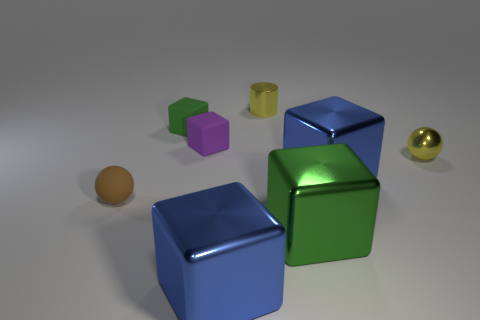Subtract all purple cubes. How many cubes are left? 4 Subtract all green matte blocks. How many blocks are left? 4 Subtract all brown blocks. Subtract all brown cylinders. How many blocks are left? 5 Add 2 big blue metal objects. How many objects exist? 10 Subtract all balls. How many objects are left? 6 Add 5 small yellow balls. How many small yellow balls are left? 6 Add 5 small green things. How many small green things exist? 6 Subtract 2 green blocks. How many objects are left? 6 Subtract all large gray shiny spheres. Subtract all green metal objects. How many objects are left? 7 